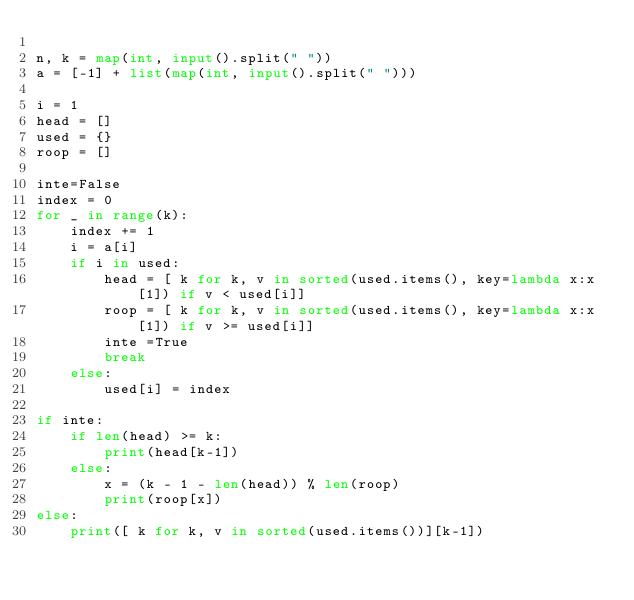<code> <loc_0><loc_0><loc_500><loc_500><_Python_>
n, k = map(int, input().split(" "))
a = [-1] + list(map(int, input().split(" ")))

i = 1
head = []
used = {}
roop = []

inte=False
index = 0
for _ in range(k):
    index += 1
    i = a[i]
    if i in used:
        head = [ k for k, v in sorted(used.items(), key=lambda x:x[1]) if v < used[i]]
        roop = [ k for k, v in sorted(used.items(), key=lambda x:x[1]) if v >= used[i]]
        inte =True
        break
    else:
        used[i] = index

if inte:
    if len(head) >= k:
        print(head[k-1])
    else:
        x = (k - 1 - len(head)) % len(roop)
        print(roop[x])
else:
    print([ k for k, v in sorted(used.items())][k-1])</code> 